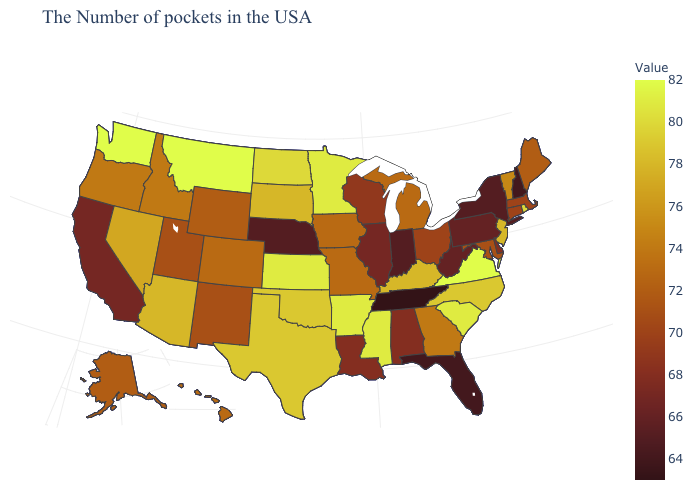Among the states that border Virginia , which have the lowest value?
Short answer required. Tennessee. Among the states that border West Virginia , which have the lowest value?
Answer briefly. Pennsylvania. Among the states that border Tennessee , which have the highest value?
Keep it brief. Virginia. Among the states that border California , which have the highest value?
Concise answer only. Arizona. 